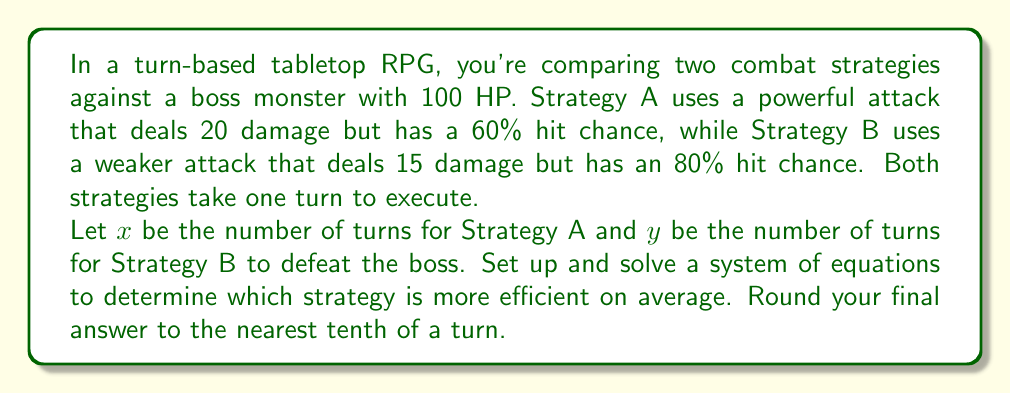Can you answer this question? Let's approach this step-by-step:

1) First, we need to calculate the expected damage per turn for each strategy:

   Strategy A: $20 \times 0.60 = 12$ damage per turn
   Strategy B: $15 \times 0.80 = 12$ damage per turn

2) Now, we can set up our system of equations. The total damage dealt should equal the boss's HP:

   For Strategy A: $12x = 100$
   For Strategy B: $12y = 100$

3) Solving these equations:

   $x = 100 / 12 = 8.33333...$
   $y = 100 / 12 = 8.33333...$

4) Rounding to the nearest tenth:

   $x \approx 8.3$ turns
   $y \approx 8.3$ turns

5) Since both strategies take the same average number of turns, they are equally efficient.

This result might seem counterintuitive at first, but it demonstrates that in a turn-based system, what matters most is the expected damage per turn, not necessarily the power or accuracy of individual attacks.
Answer: Both strategies are equally efficient, taking an average of 8.3 turns to defeat the boss. 